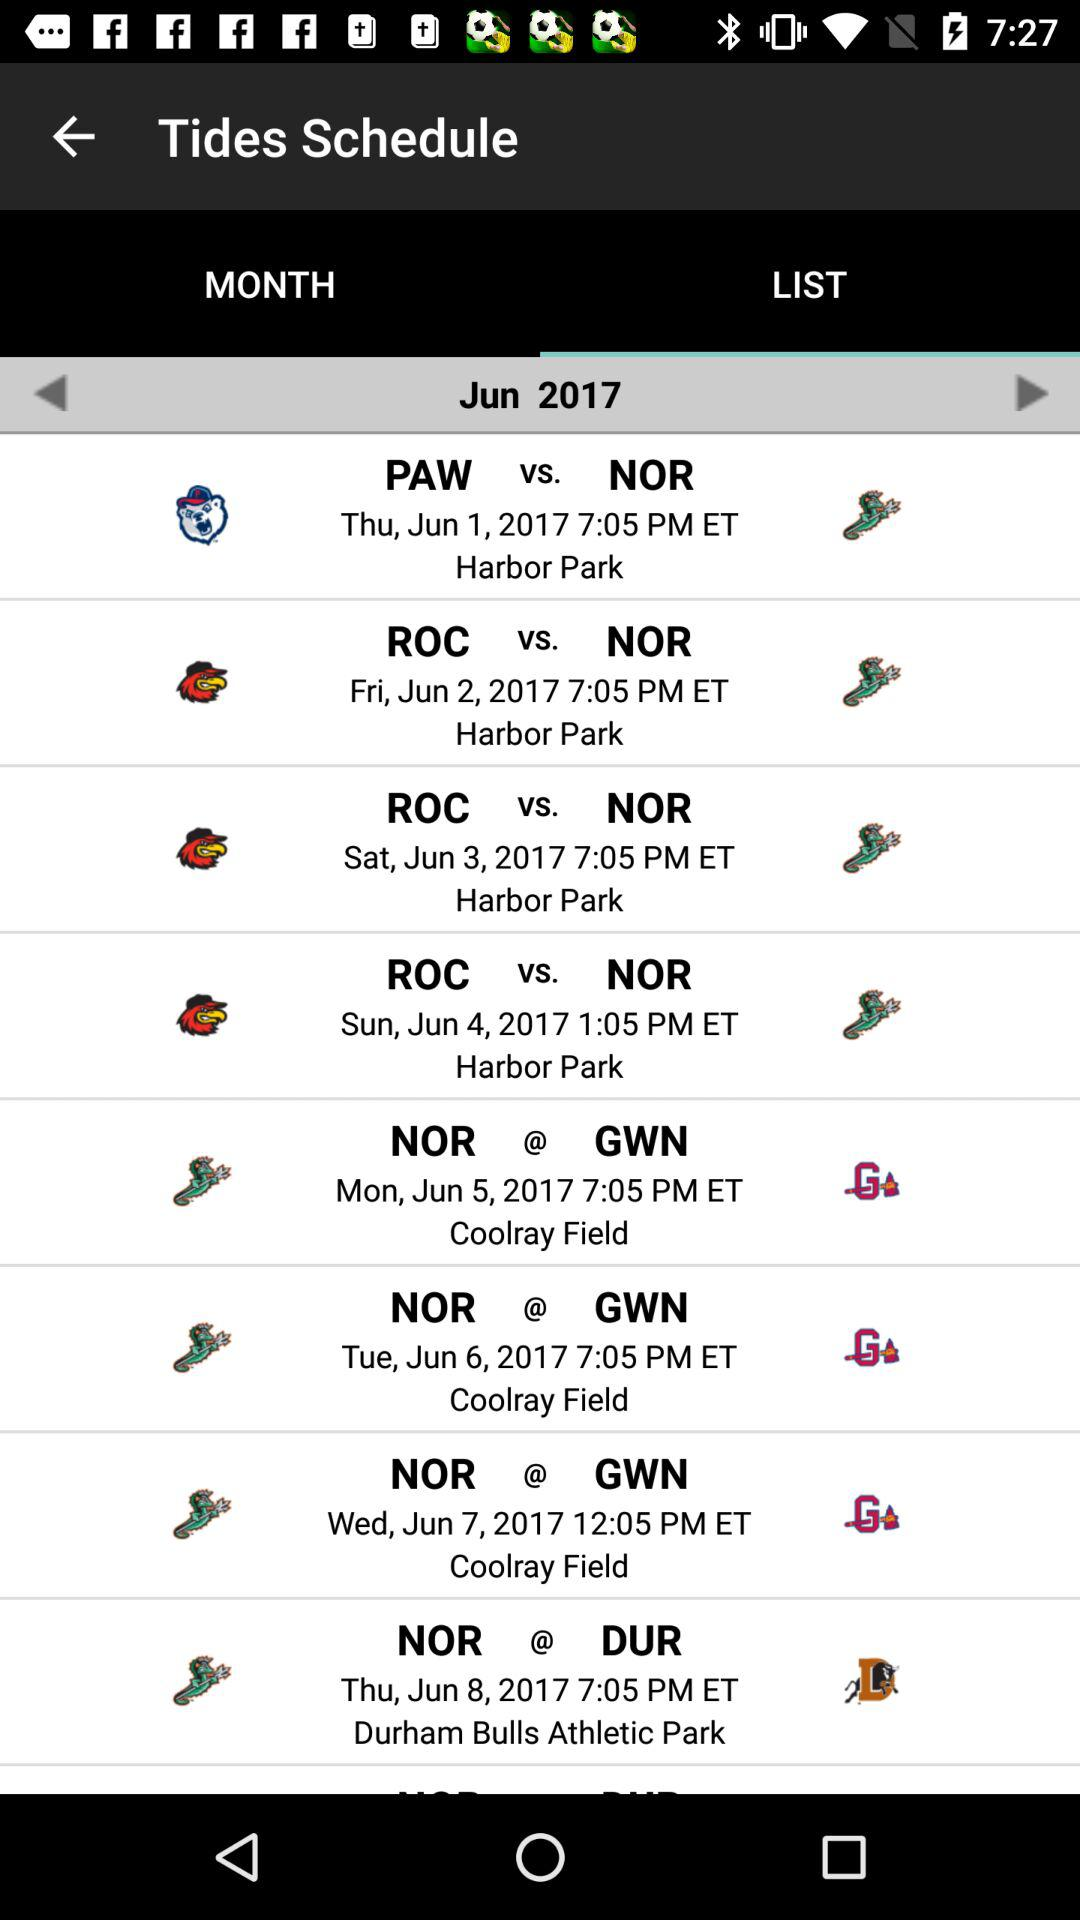What is the last match date? The date for the last match is Thursday, June 8, 2017. 